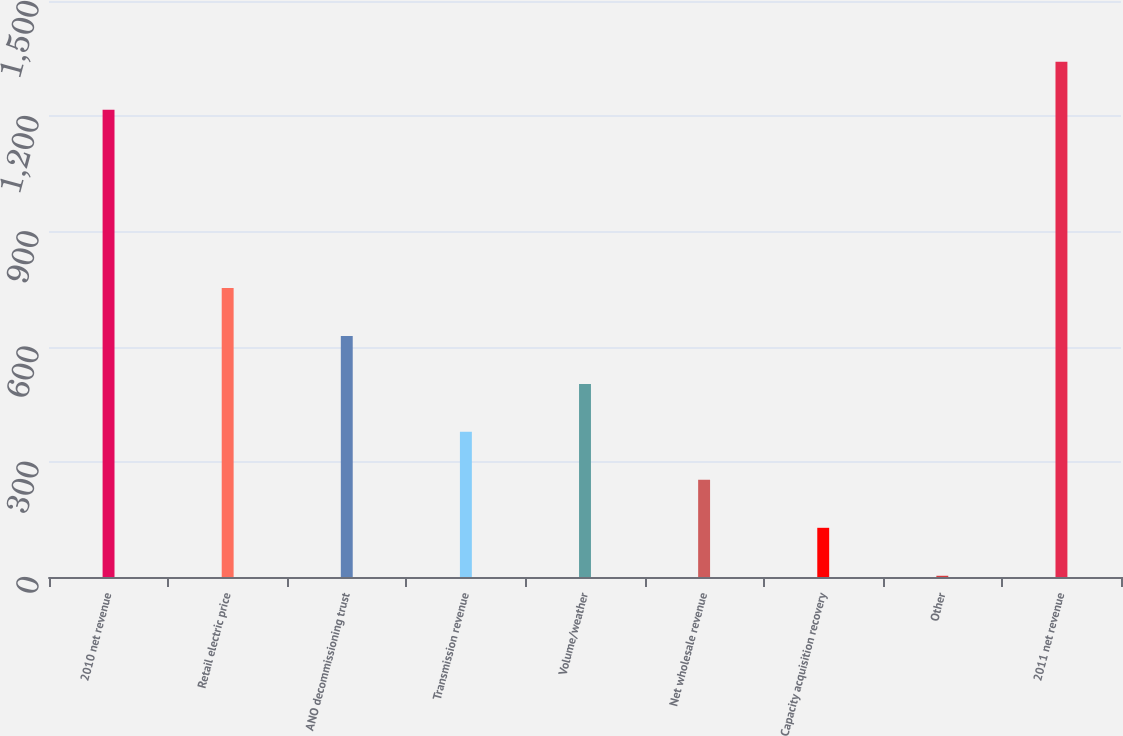Convert chart to OTSL. <chart><loc_0><loc_0><loc_500><loc_500><bar_chart><fcel>2010 net revenue<fcel>Retail electric price<fcel>ANO decommissioning trust<fcel>Transmission revenue<fcel>Volume/weather<fcel>Net wholesale revenue<fcel>Capacity acquisition recovery<fcel>Other<fcel>2011 net revenue<nl><fcel>1216.7<fcel>752.66<fcel>627.75<fcel>377.93<fcel>502.84<fcel>253.02<fcel>128.11<fcel>3.2<fcel>1341.61<nl></chart> 